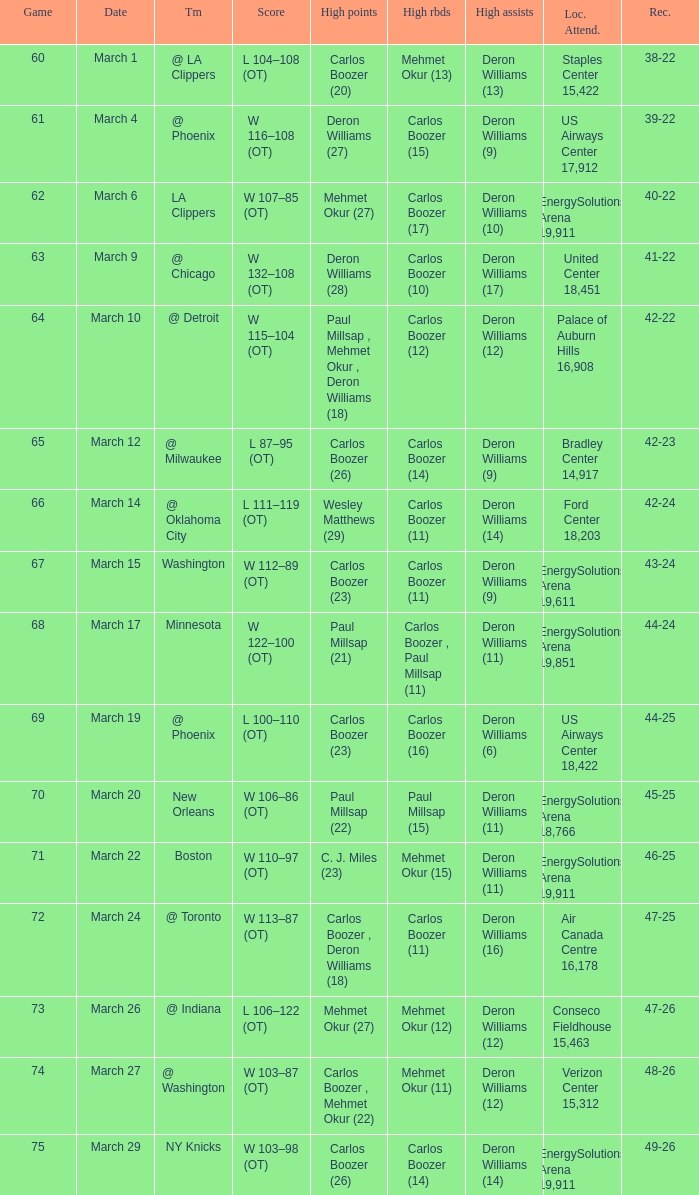What was the record at the game where Deron Williams (6) did the high assists? 44-25. 